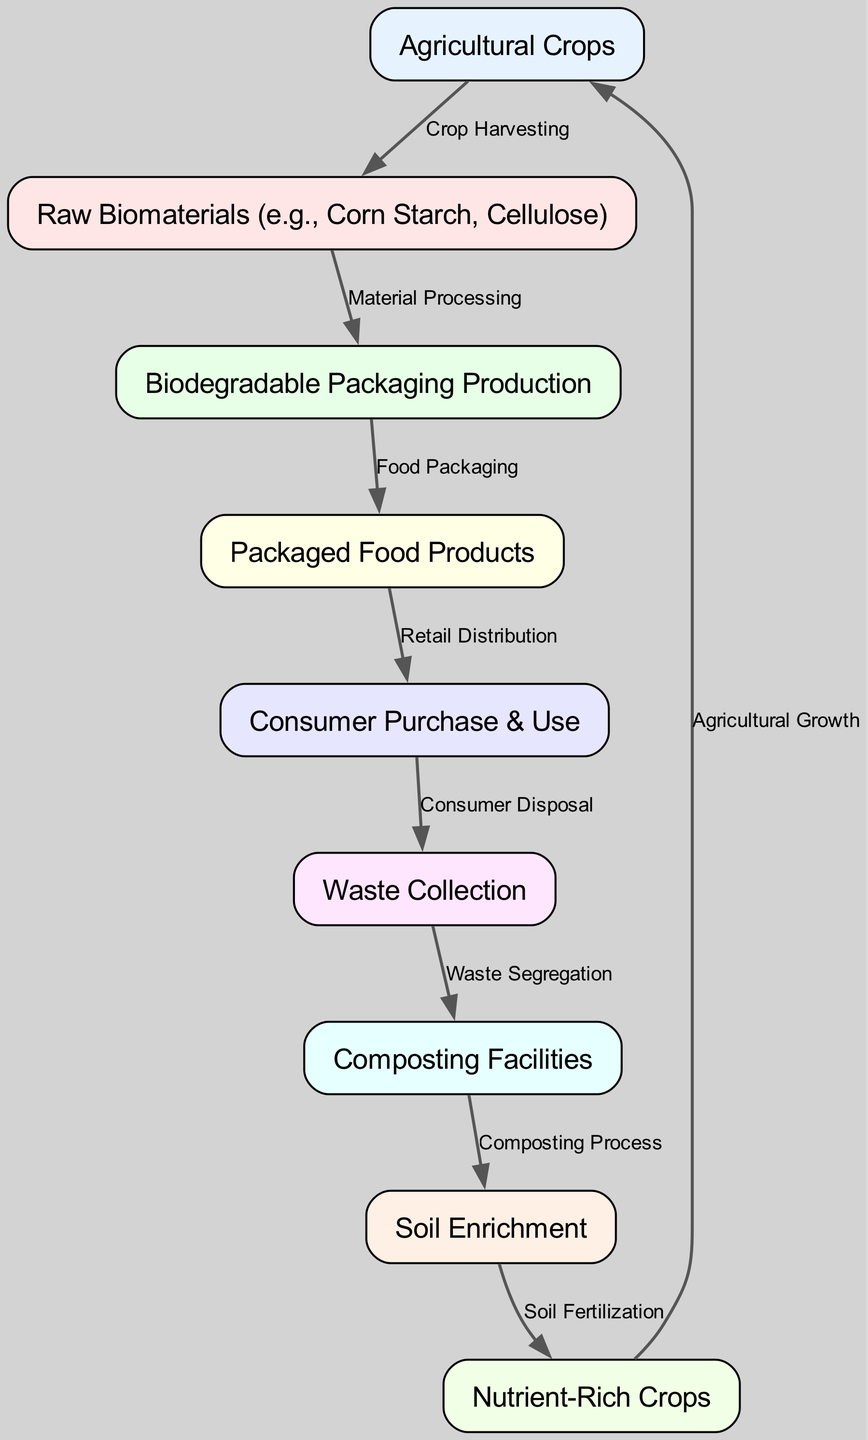What is the first node in the food chain? The first node listed in the diagram is "Agricultural Crops," which represents the starting point of the food chain.
Answer: Agricultural Crops How many nodes are in the diagram? The diagram contains a total of nine nodes representing different elements in the food chain.
Answer: 9 What is the relationship between Raw Biomaterials and Biodegradable Packaging Production? The diagram shows that Raw Biomaterials are processed in the step labeled "Material Processing," leading to Biodegradable Packaging Production, indicating that raw materials are necessary for producing packaging.
Answer: Material Processing What process connects Packaged Food Products to Consumer Purchase & Use? The arrow labeled "Retail Distribution" in the diagram indicates the process that connects Packaged Food Products to Consumer Purchase & Use. This means that food products are distributed in retail settings before consumers purchase them.
Answer: Retail Distribution What happens to waste after Consumer Disposal? According to the diagram, after Consumer Disposal, waste goes through a process labeled "Waste Segregation," which is preparation for further processing of waste materials.
Answer: Waste Segregation Which node is directly connected to Composting Facilities? The node directly connected to Composting Facilities is "Waste Collection," indicating that waste must be collected before it can be processed at composting facilities.
Answer: Waste Collection What is the final outcome before returning to Agricultural Crops? The last step before returning to Agricultural Crops is "Soil Enrichment." This indicates that the enriching of soil is necessary to promote agricultural growth.
Answer: Soil Enrichment How do Nutrient-Rich Crops relate back to Agricultural Crops? The diagram shows that Nutrient-Rich Crops contribute positively back to Agricultural Growth, suggesting a cyclical relationship where enriched soil produces better-quality crops.
Answer: Agricultural Growth What is the last node in the food chain? The last node connected back to the beginning of the chain is "Nutrient-Rich Crops," which suggests that the cycle completes by promoting new agricultural crops.
Answer: Nutrient-Rich Crops 